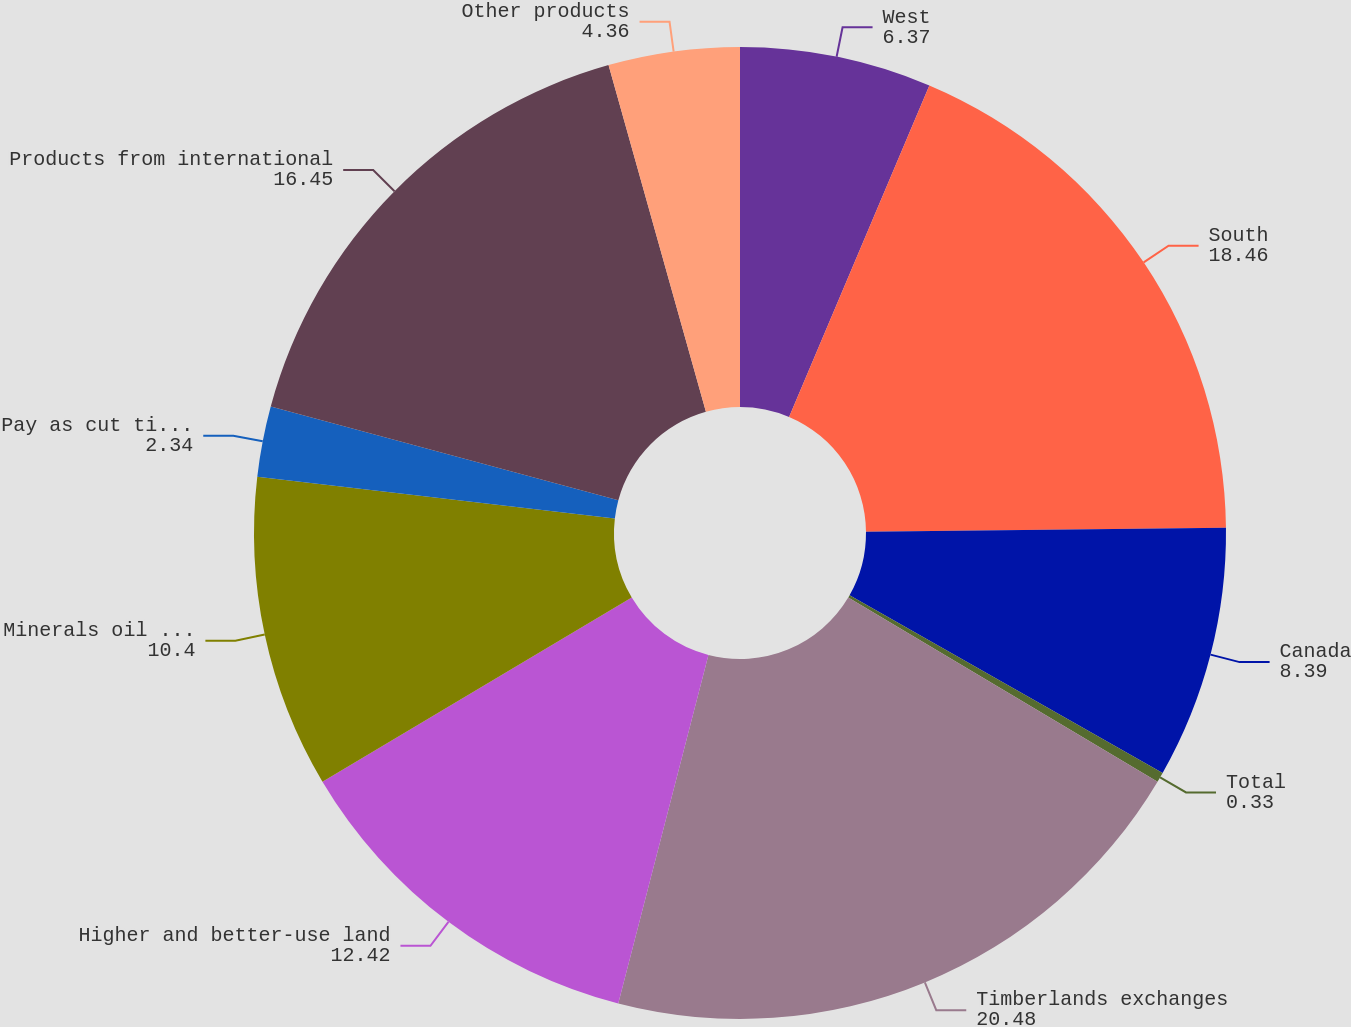Convert chart. <chart><loc_0><loc_0><loc_500><loc_500><pie_chart><fcel>West<fcel>South<fcel>Canada<fcel>Total<fcel>Timberlands exchanges<fcel>Higher and better-use land<fcel>Minerals oil and gas<fcel>Pay as cut timber sales<fcel>Products from international<fcel>Other products<nl><fcel>6.37%<fcel>18.46%<fcel>8.39%<fcel>0.33%<fcel>20.48%<fcel>12.42%<fcel>10.4%<fcel>2.34%<fcel>16.45%<fcel>4.36%<nl></chart> 